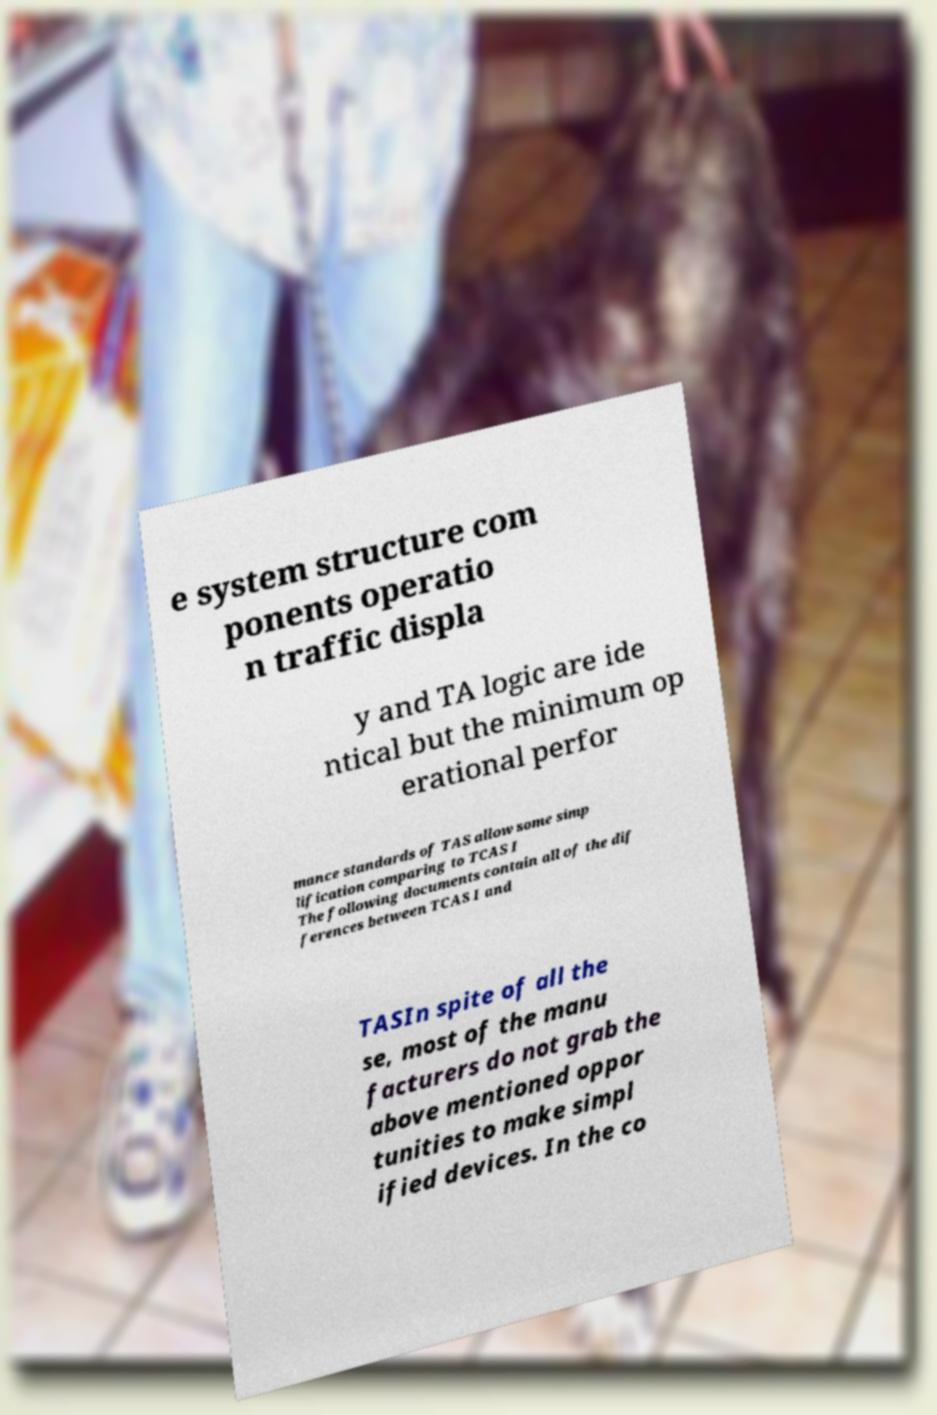Please read and relay the text visible in this image. What does it say? e system structure com ponents operatio n traffic displa y and TA logic are ide ntical but the minimum op erational perfor mance standards of TAS allow some simp lification comparing to TCAS I The following documents contain all of the dif ferences between TCAS I and TASIn spite of all the se, most of the manu facturers do not grab the above mentioned oppor tunities to make simpl ified devices. In the co 